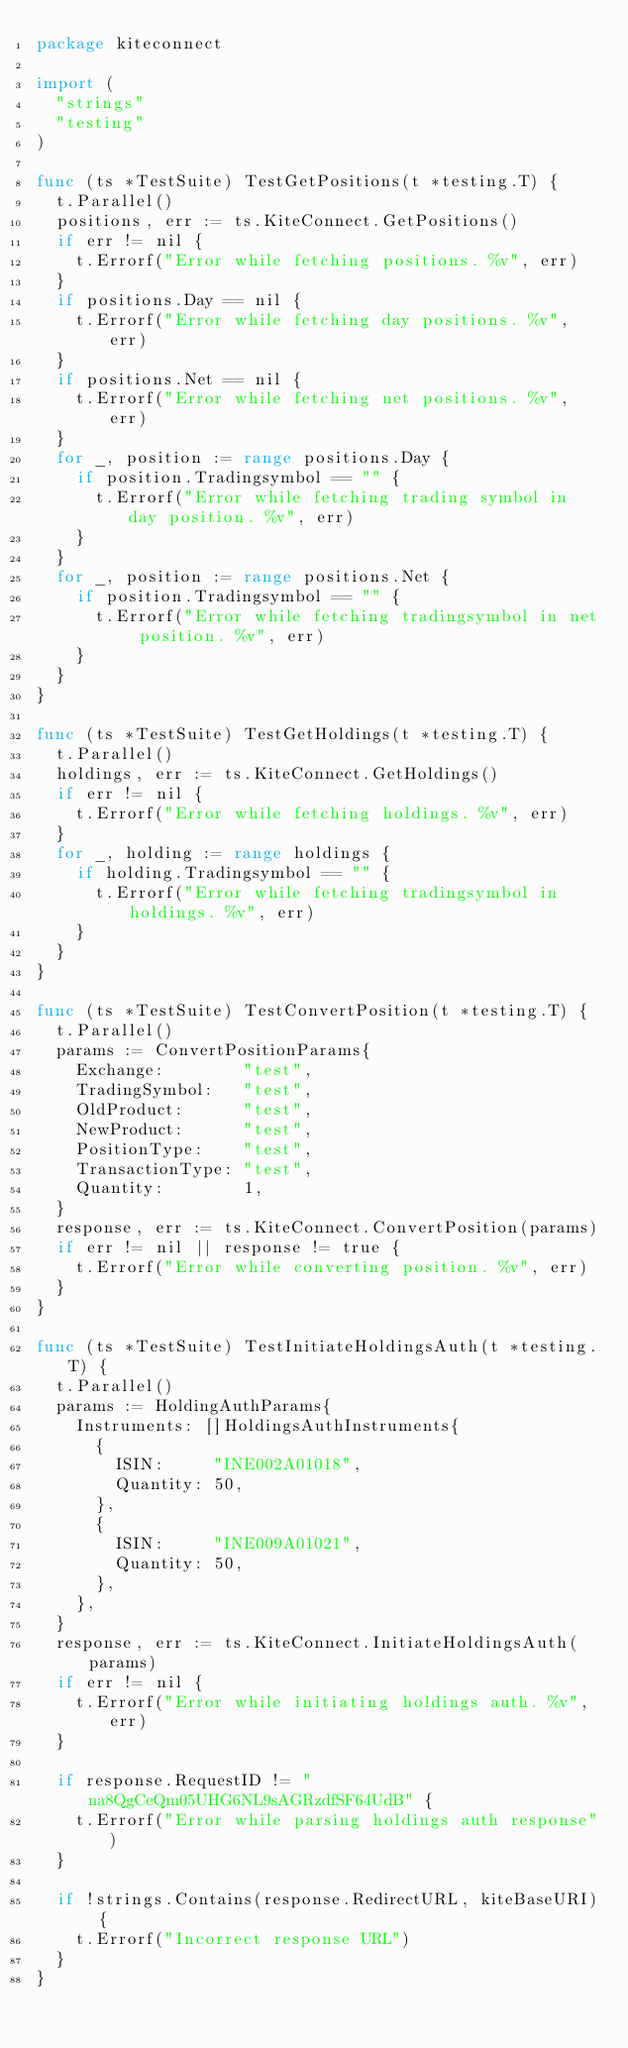<code> <loc_0><loc_0><loc_500><loc_500><_Go_>package kiteconnect

import (
	"strings"
	"testing"
)

func (ts *TestSuite) TestGetPositions(t *testing.T) {
	t.Parallel()
	positions, err := ts.KiteConnect.GetPositions()
	if err != nil {
		t.Errorf("Error while fetching positions. %v", err)
	}
	if positions.Day == nil {
		t.Errorf("Error while fetching day positions. %v", err)
	}
	if positions.Net == nil {
		t.Errorf("Error while fetching net positions. %v", err)
	}
	for _, position := range positions.Day {
		if position.Tradingsymbol == "" {
			t.Errorf("Error while fetching trading symbol in day position. %v", err)
		}
	}
	for _, position := range positions.Net {
		if position.Tradingsymbol == "" {
			t.Errorf("Error while fetching tradingsymbol in net position. %v", err)
		}
	}
}

func (ts *TestSuite) TestGetHoldings(t *testing.T) {
	t.Parallel()
	holdings, err := ts.KiteConnect.GetHoldings()
	if err != nil {
		t.Errorf("Error while fetching holdings. %v", err)
	}
	for _, holding := range holdings {
		if holding.Tradingsymbol == "" {
			t.Errorf("Error while fetching tradingsymbol in holdings. %v", err)
		}
	}
}

func (ts *TestSuite) TestConvertPosition(t *testing.T) {
	t.Parallel()
	params := ConvertPositionParams{
		Exchange:        "test",
		TradingSymbol:   "test",
		OldProduct:      "test",
		NewProduct:      "test",
		PositionType:    "test",
		TransactionType: "test",
		Quantity:        1,
	}
	response, err := ts.KiteConnect.ConvertPosition(params)
	if err != nil || response != true {
		t.Errorf("Error while converting position. %v", err)
	}
}

func (ts *TestSuite) TestInitiateHoldingsAuth(t *testing.T) {
	t.Parallel()
	params := HoldingAuthParams{
		Instruments: []HoldingsAuthInstruments{
			{
				ISIN:     "INE002A01018",
				Quantity: 50,
			},
			{
				ISIN:     "INE009A01021",
				Quantity: 50,
			},
		},
	}
	response, err := ts.KiteConnect.InitiateHoldingsAuth(params)
	if err != nil {
		t.Errorf("Error while initiating holdings auth. %v", err)
	}

	if response.RequestID != "na8QgCeQm05UHG6NL9sAGRzdfSF64UdB" {
		t.Errorf("Error while parsing holdings auth response")
	}

	if !strings.Contains(response.RedirectURL, kiteBaseURI) {
		t.Errorf("Incorrect response URL")
	}
}
</code> 